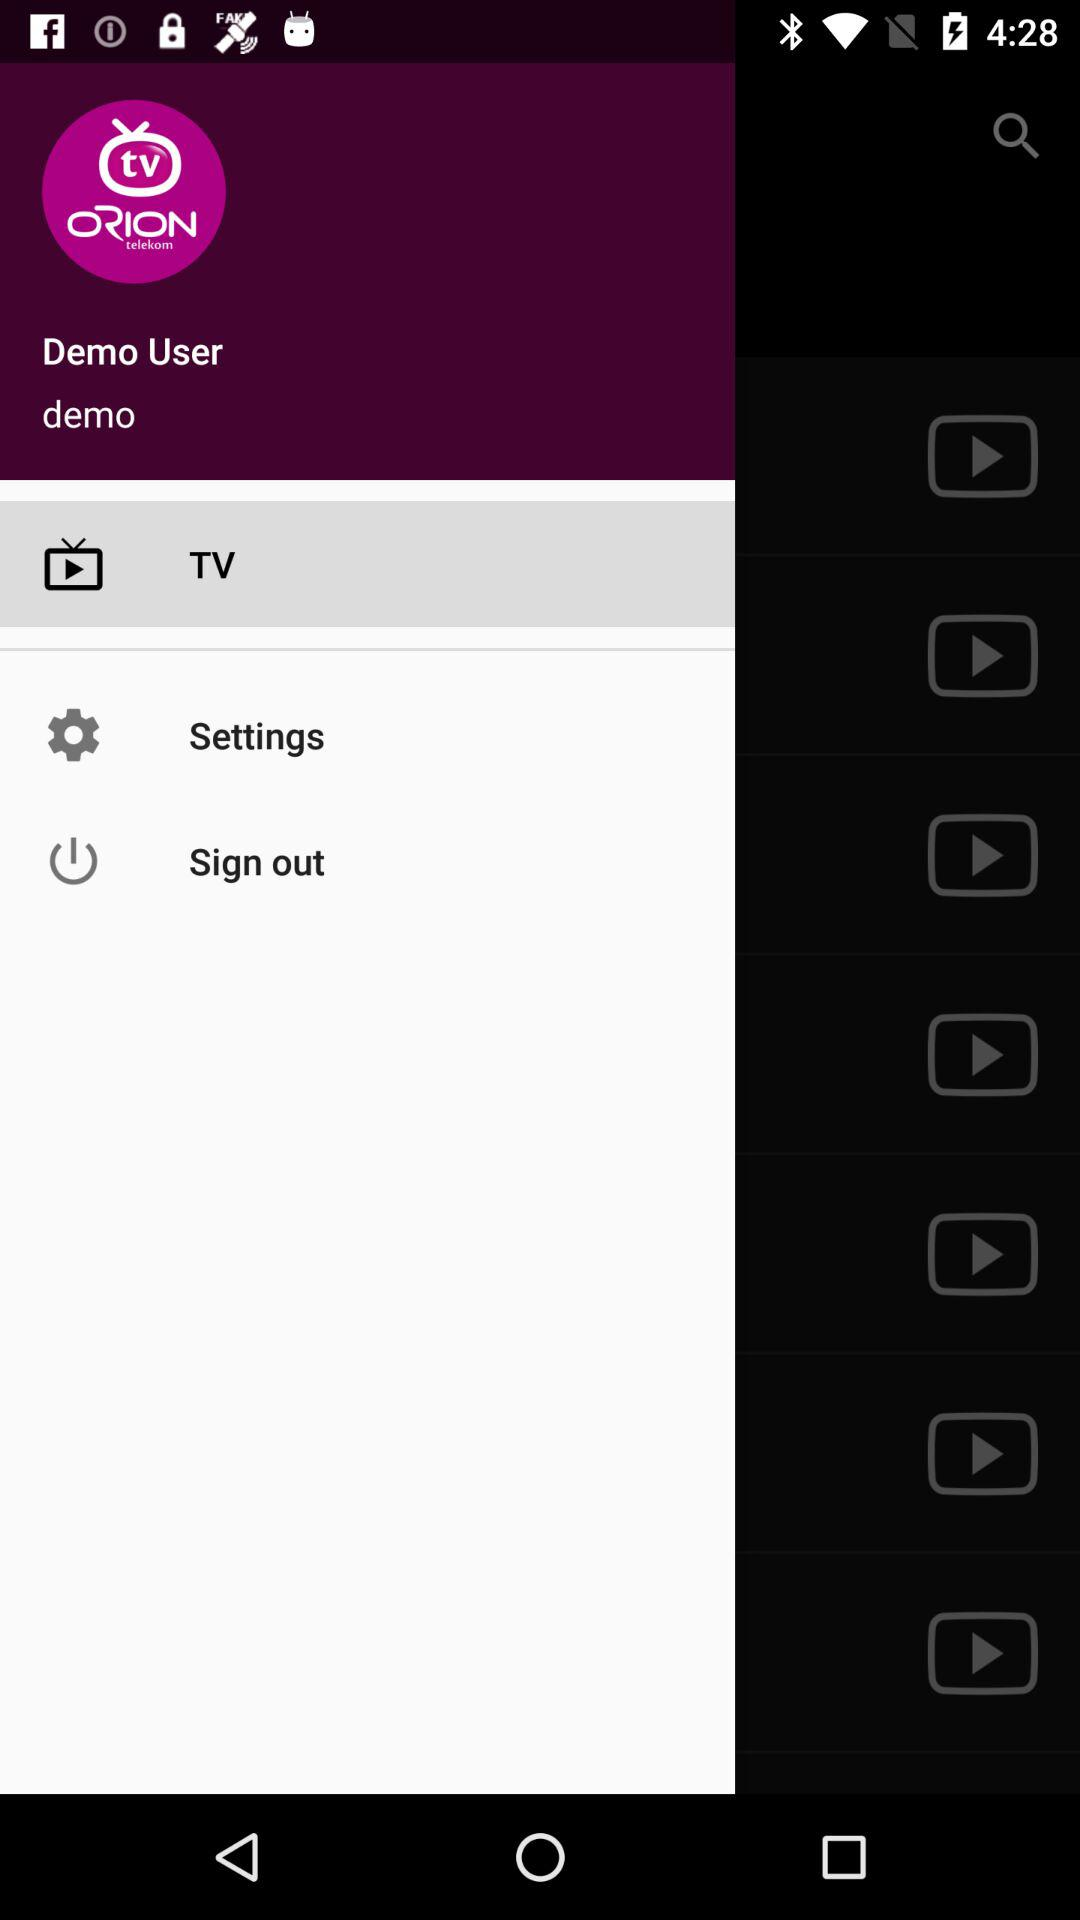What is the name of the application? The name of the application is "Orion TV". 